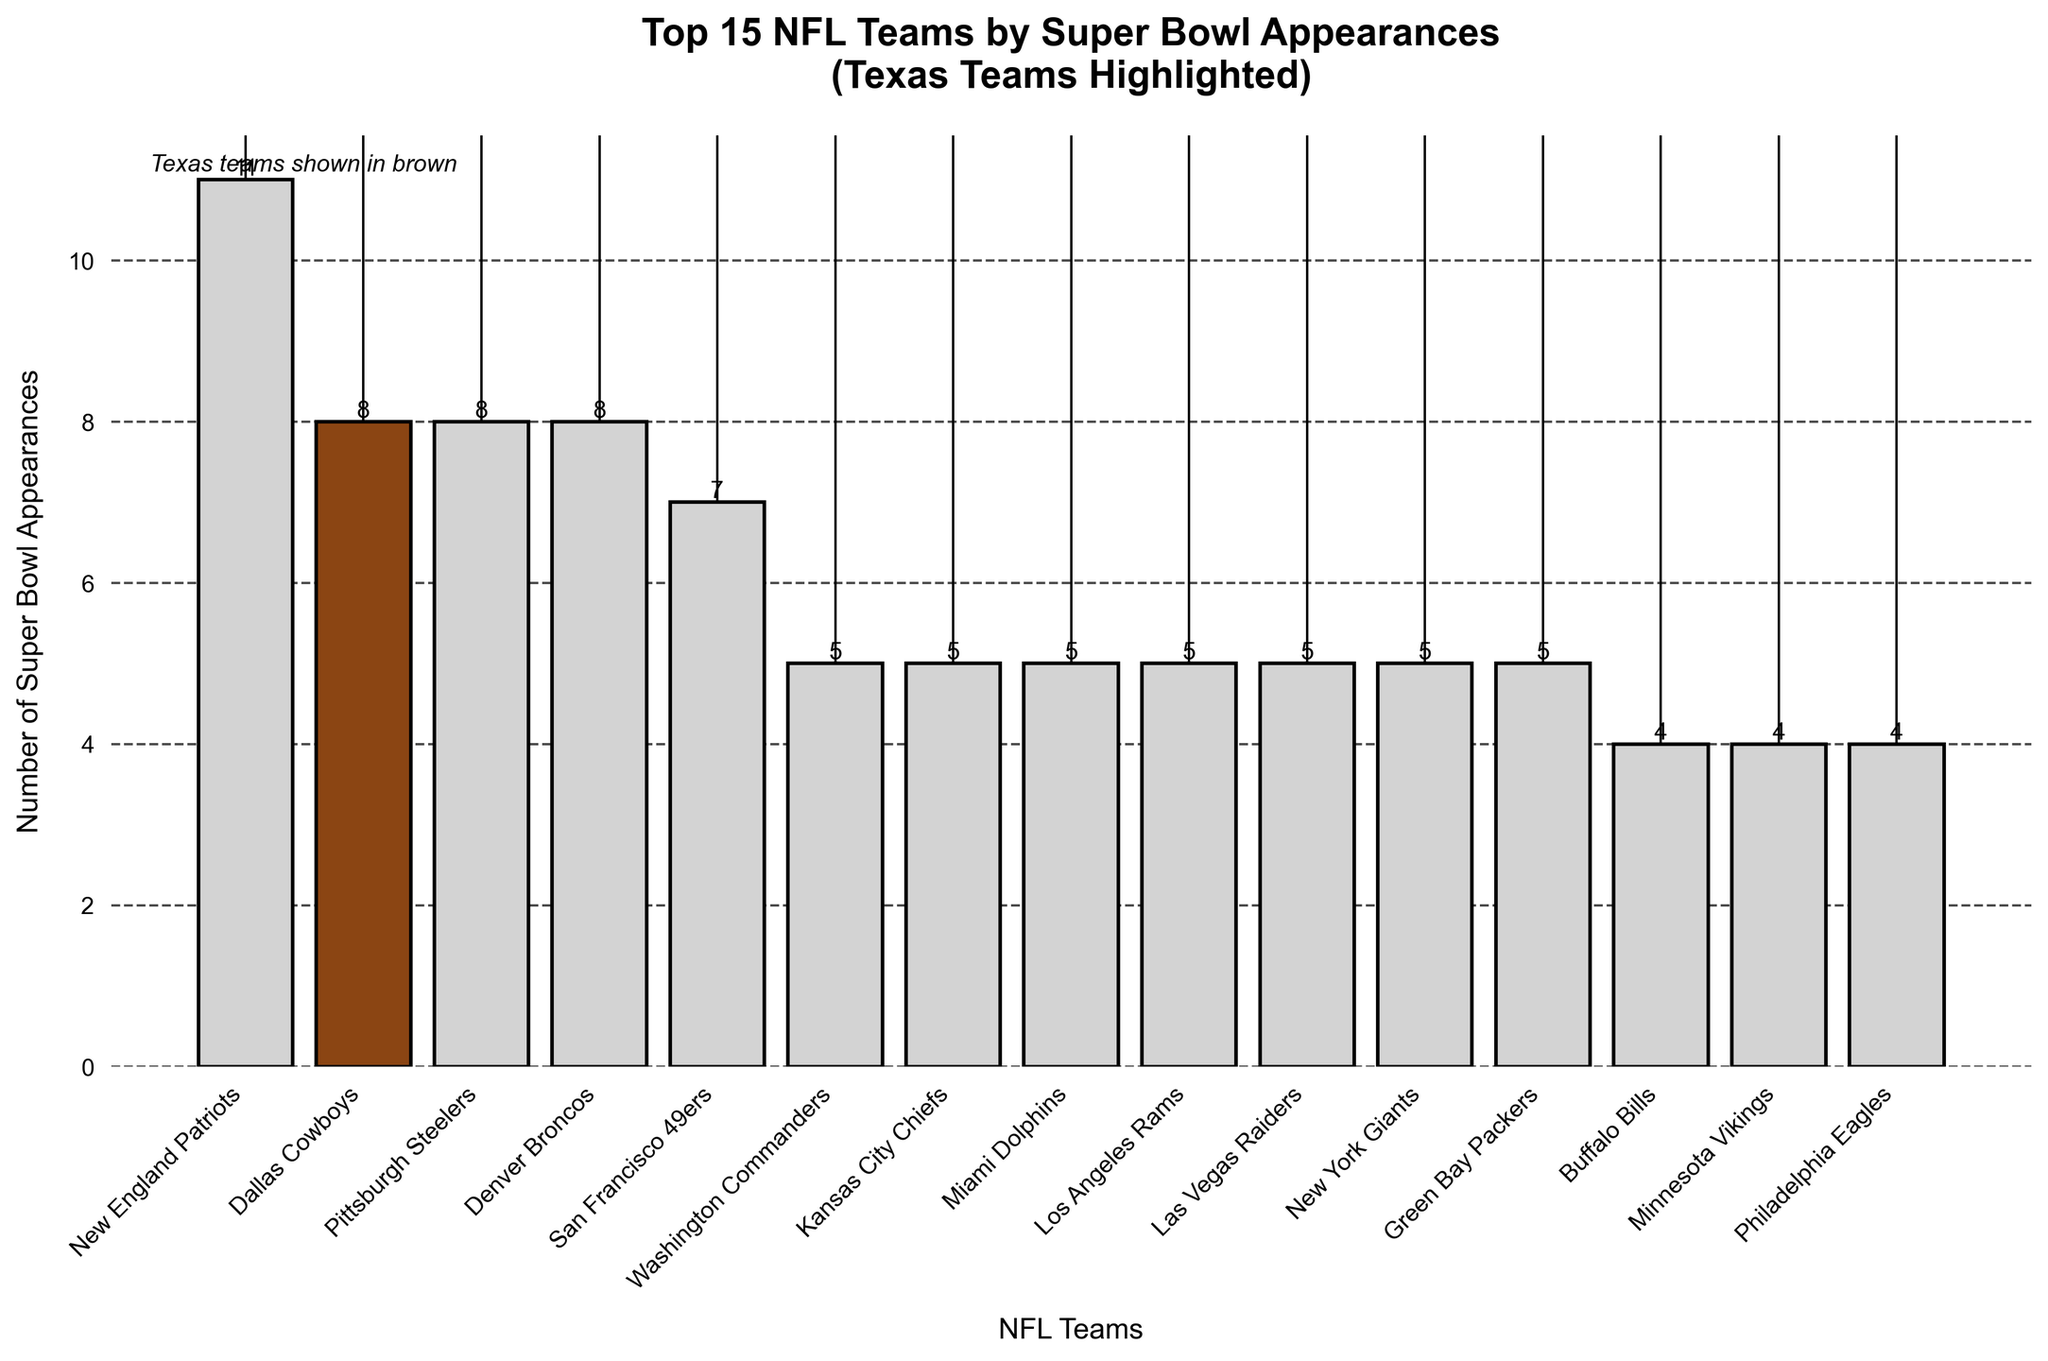Which team has the highest number of Super Bowl appearances? To find the team with the highest number of Super Bowl appearances, we look for the tallest bar in the chart. The tallest bar corresponds to the New England Patriots.
Answer: New England Patriots How many teams have more Super Bowl appearances than the Dallas Cowboys? The Dallas Cowboys have 8 appearances. By counting the bars taller than 8, only the New England Patriots (11 appearances) have more.
Answer: 1 Which Texas team has the highest number of Super Bowl appearances? By looking for bars highlighted in brown representing Texas teams, the Dallas Cowboys with 8 appearances is the highest among Texas teams.
Answer: Dallas Cowboys What is the sum of the Super Bowl appearances of all Texas teams shown in the figure? The Dallas Cowboys have 8, the Houston Texans have 0, and the Houston Oilers/Tennessee Titans have 1. Summing these values gives 8 + 0 + 1.
Answer: 9 How many Super Bowl appearances do the Pittsburgh Steelers and Denver Broncos have combined? The bar for Pittsburgh Steelers is labeled with 8 and the bar for Denver Broncos is also labeled with 8. Adding these values gives 8 + 8.
Answer: 16 Which non-Texas team has the same number of Super Bowl appearances as the Dallas Cowboys? The Dallas Cowboys have 8 appearances. The non-Texas team with a bar of the same height is the Pittsburgh Steelers and Denver Broncos.
Answer: Pittsburgh Steelers, Denver Broncos Which team has the least number of Super Bowl appearances among those listed in the figure? By looking for the shortest bar in the chart, the Houston Texans have the shortest bar with 0 appearances.
Answer: Houston Texans Are there more teams with fewer Super Bowl appearances than the Dallas Cowboys or with more? The Dallas Cowboys have 8 appearances. We count the teams with fewer (Pittsburgh Steelers, Denver Broncos, Green Bay Packers, all others) and more (only New England Patriots, with 11). More teams have fewer appearances.
Answer: Fewer Which Texas team appears in the top 15 teams by Super Bowl appearances? The top 15 teams are shown in the chart, and the Texas team among them with high appearances is the Dallas Cowboys.
Answer: Dallas Cowboys How does the Super Bowl appearance count of the Kansas City Chiefs compare to the Green Bay Packers? We refer to the heights of the bars: Kansas City Chiefs have 5 appearances, and Green Bay Packers also have 5. Both teams have the same number of appearances.
Answer: Equal 